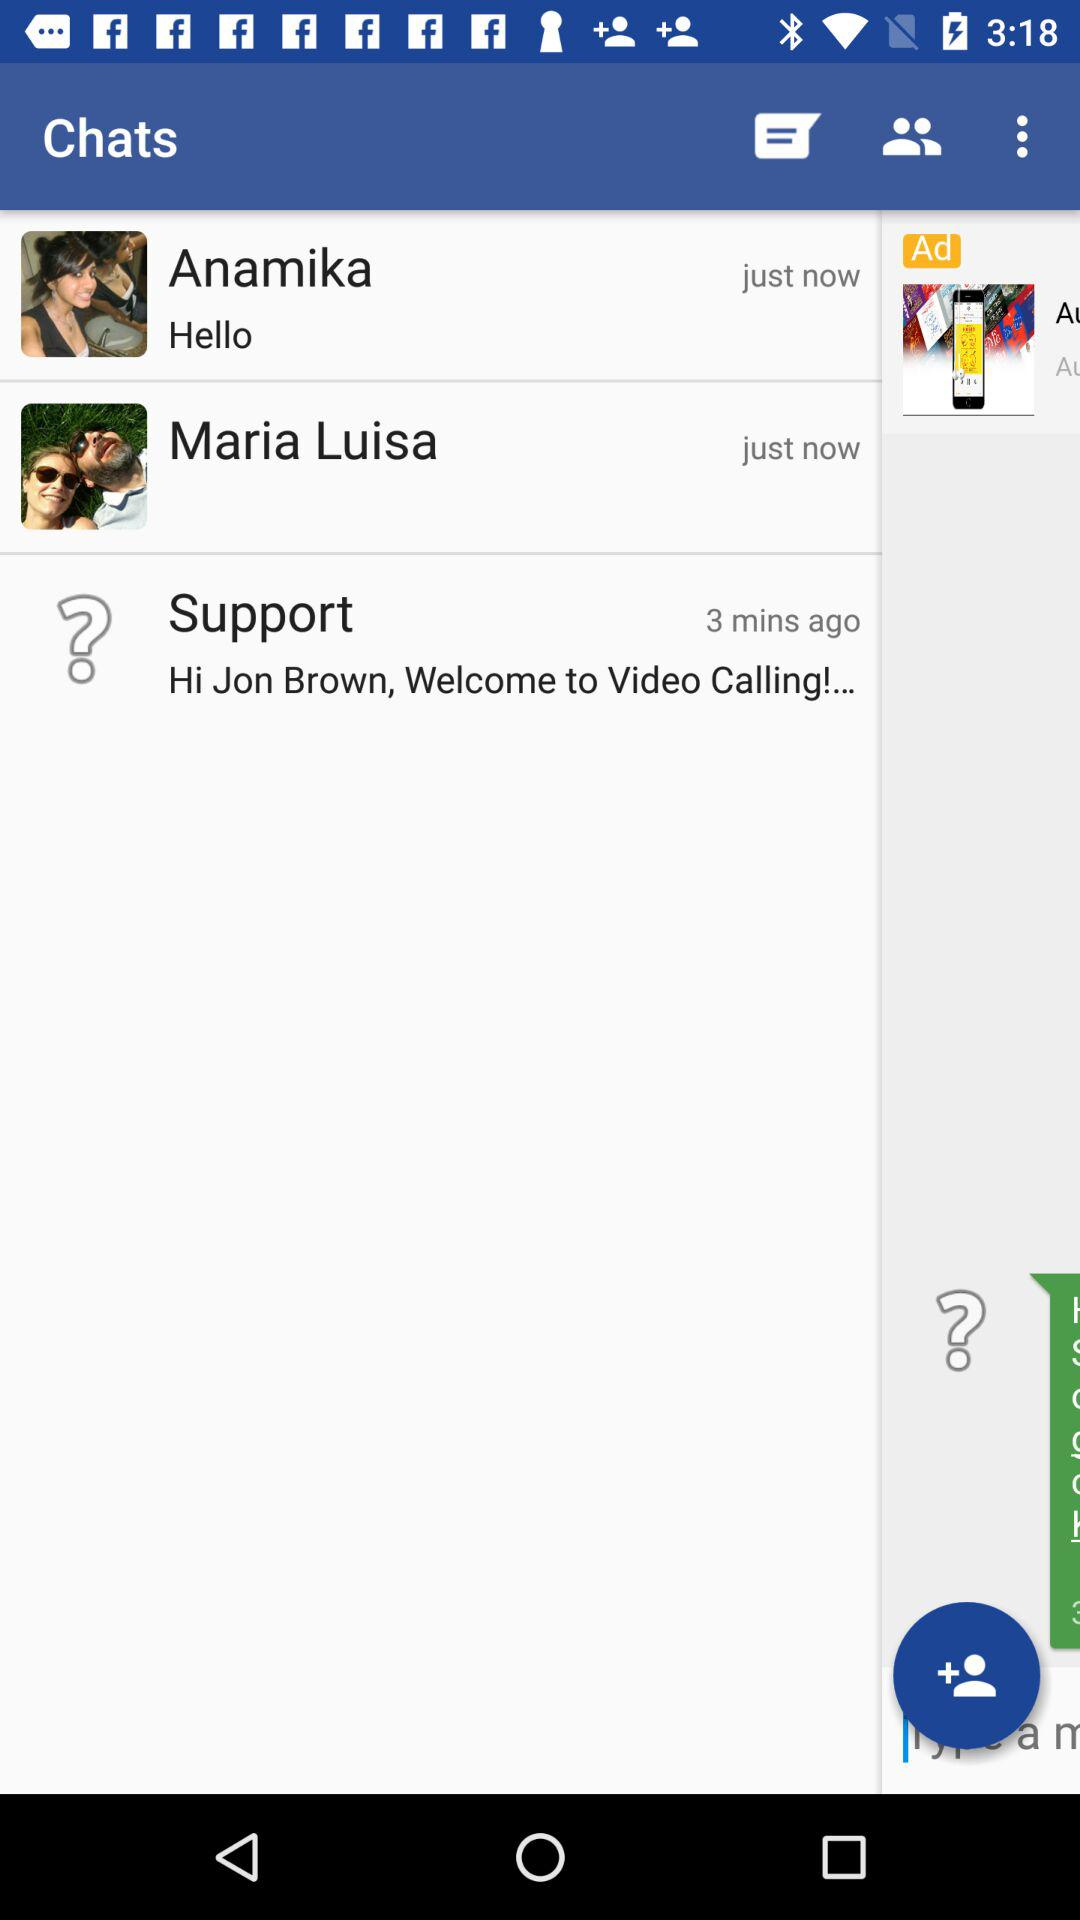When did Anamika's message come? Anamika's message arrived just now. 